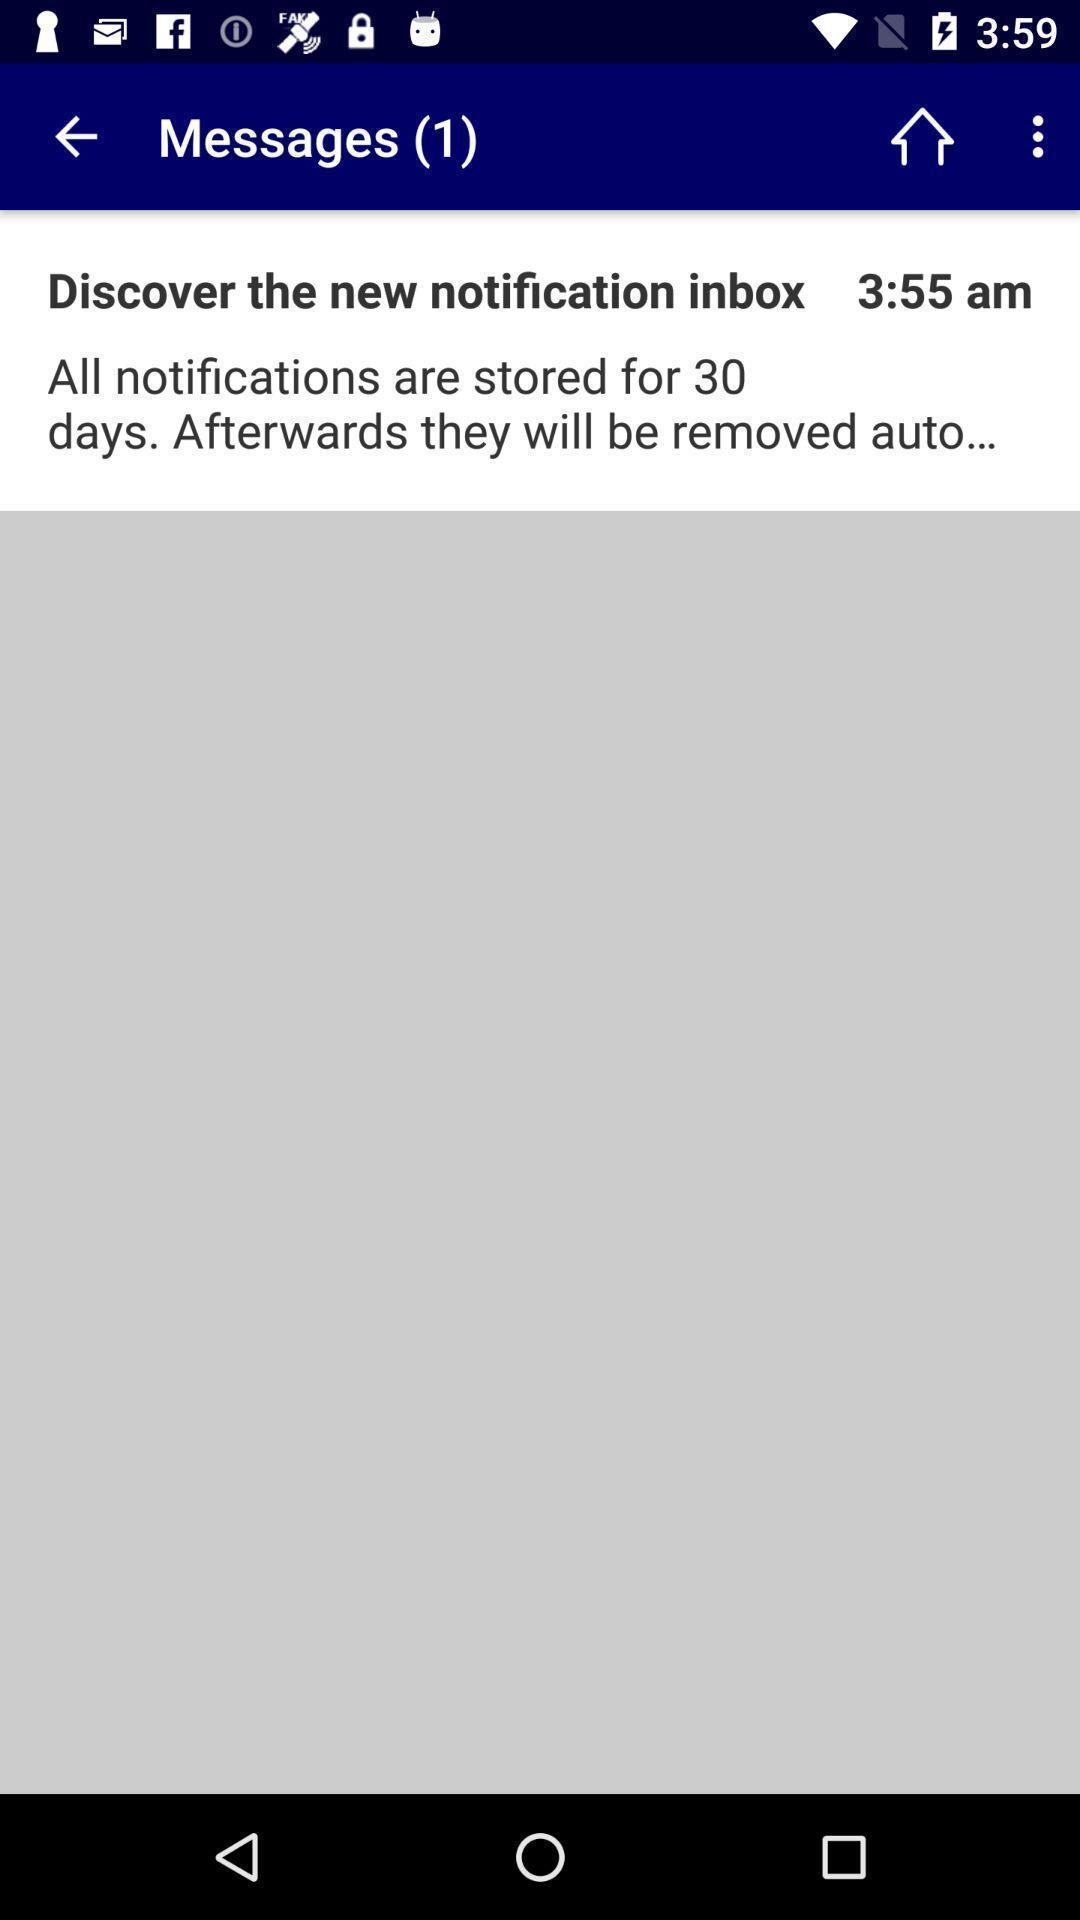What details can you identify in this image? Page shows the message notification inbox on booking app. 